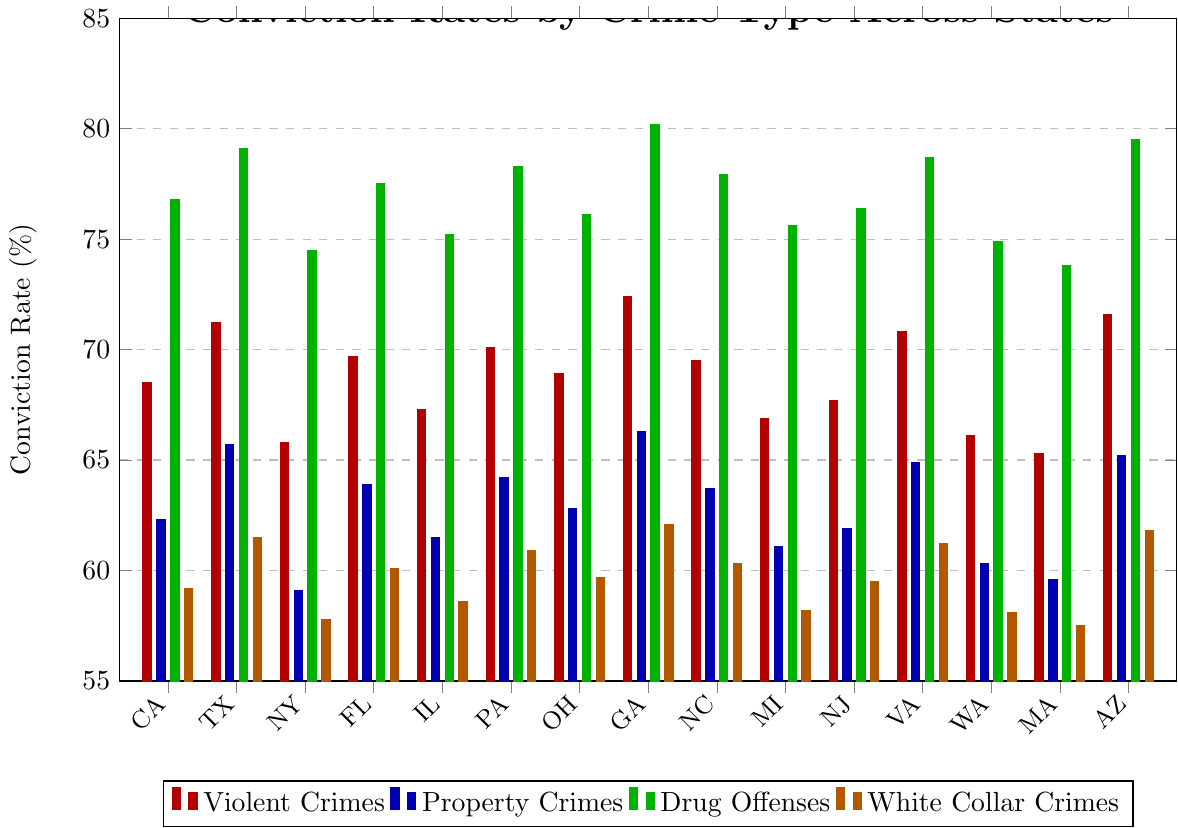what state has the highest conviction rate for drug offenses? To find the state with the highest conviction rate for drug offenses, look at the green bars. Identify the tallest green bar, which corresponds to Georgia with a conviction rate of 80.2%.
Answer: Georgia What is the difference in the conviction rates for white-collar crimes between New York and California? First, find the blue bars for New York, which is 57.8%, and then for California, which is 59.2%. Subtract the New York rate from the California rate: 59.2% - 57.8% = 1.4%.
Answer: 1.4% What is the approximate average conviction rate for violent crimes across all states? To find the average, sum the conviction rates for violent crimes across all states and divide by the number of states. (68.5 + 71.2 + 65.8 + 69.7 + 67.3 + 70.1 + 68.9 + 72.4 + 69.5 + 66.9 + 67.7 + 70.8 + 66.1 + 65.3 + 71.6) / 15 = 69%.
Answer: 69% Which state has the lowest conviction rate for property crimes? Scan the bars associated with property crimes (blue) and identify the shortest one, which belongs to Massachusetts at 59.6%.
Answer: Massachusetts Compare the conviction rates for drug offenses in Ohio and Texas. Which state has a higher rate, and by how much? The green bar for Ohio shows a 76.1% conviction rate, while Texas shows 79.1%. The difference is 79.1% - 76.1% = 3%. Texas has a higher rate.
Answer: Texas by 3% What is the color representation for conviction rates of white-collar crimes? The bars representing white-collar crime conviction rates are colored orange in the chart.
Answer: Orange How many states have conviction rates for property crimes above 64%? Look for blue bars above 64% and count them. These are Texas, Pennsylvania, Georgia, Virginia, and Arizona, totaling 5 states.
Answer: 5 states What is the range of conviction rates for violent crimes? Identify the highest and lowest points of the red bars from all states. The highest is Georgia with 72.4%, and the lowest is Massachusetts with 65.3%, giving a range of 72.4% - 65.3% = 7.1%.
Answer: 7.1% Which type of crime has the most consistent conviction rates across all states, and why? By visually assessing the bar heights, white-collar crimes (orange bars) show the least variability in height, indicating more consistent rates.
Answer: White-collar crimes Which state has a higher conviction rate for drug offenses, Massachusetts or Washington, and what are their rates? Massachusetts' conviction rate is 73.8% while Washington's is 74.9%. Washington has the higher rate.
Answer: Washington, 74.9% vs. 73.8% 